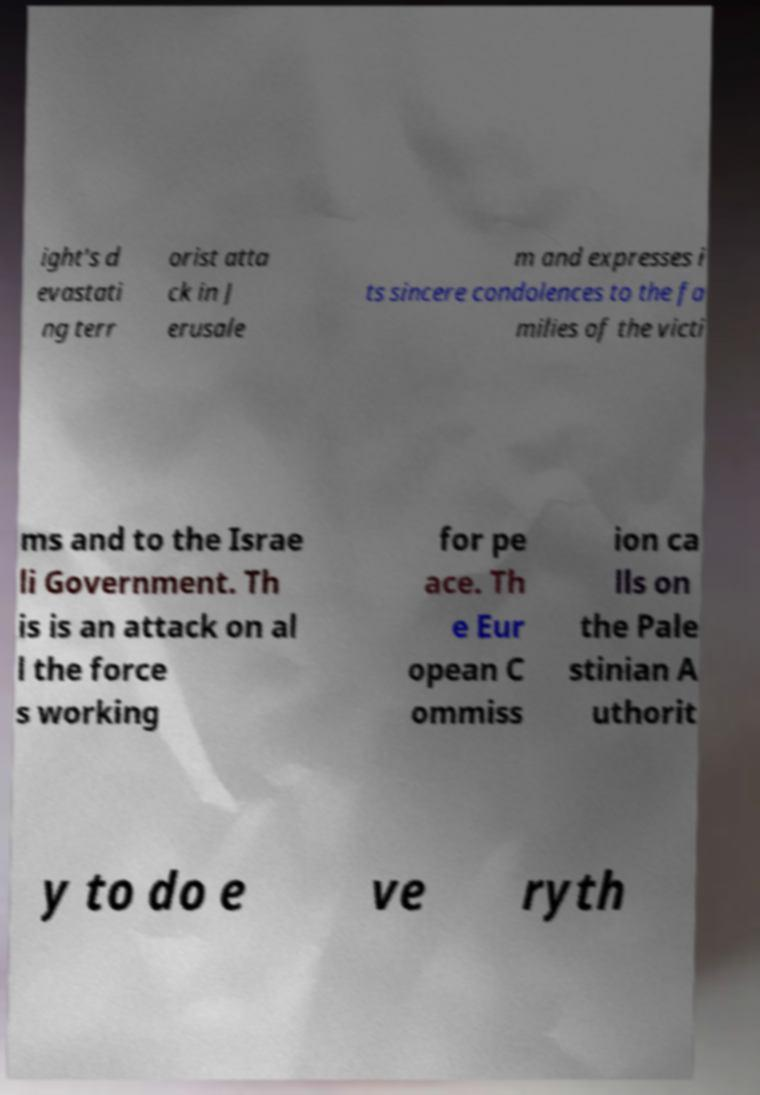There's text embedded in this image that I need extracted. Can you transcribe it verbatim? ight's d evastati ng terr orist atta ck in J erusale m and expresses i ts sincere condolences to the fa milies of the victi ms and to the Israe li Government. Th is is an attack on al l the force s working for pe ace. Th e Eur opean C ommiss ion ca lls on the Pale stinian A uthorit y to do e ve ryth 